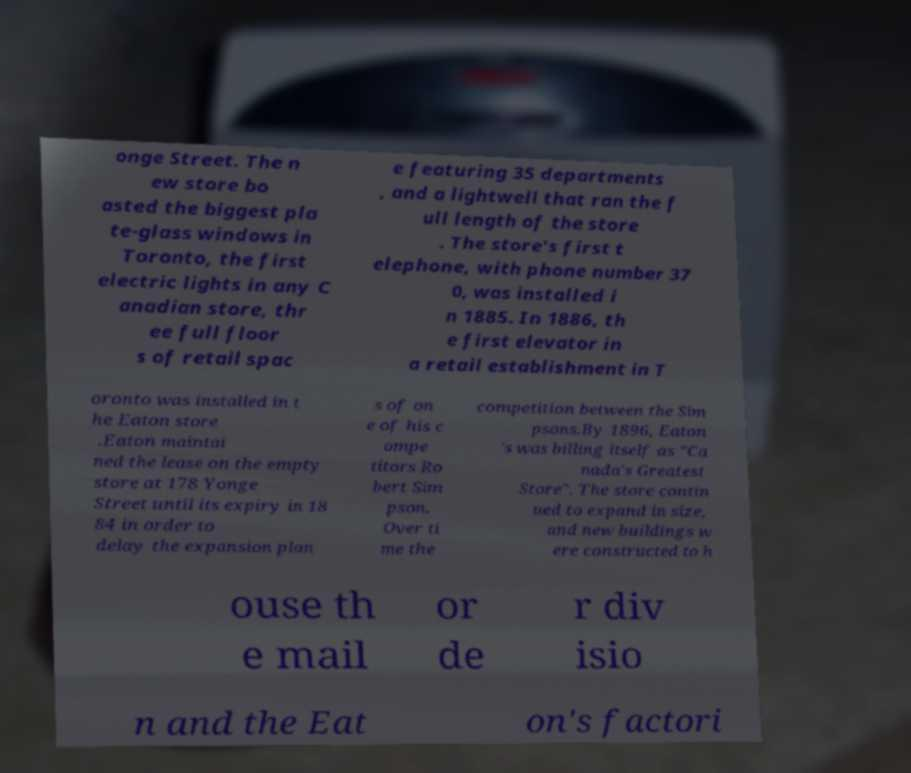I need the written content from this picture converted into text. Can you do that? onge Street. The n ew store bo asted the biggest pla te-glass windows in Toronto, the first electric lights in any C anadian store, thr ee full floor s of retail spac e featuring 35 departments , and a lightwell that ran the f ull length of the store . The store's first t elephone, with phone number 37 0, was installed i n 1885. In 1886, th e first elevator in a retail establishment in T oronto was installed in t he Eaton store .Eaton maintai ned the lease on the empty store at 178 Yonge Street until its expiry in 18 84 in order to delay the expansion plan s of on e of his c ompe titors Ro bert Sim pson. Over ti me the competition between the Sim psons.By 1896, Eaton 's was billing itself as "Ca nada's Greatest Store". The store contin ued to expand in size, and new buildings w ere constructed to h ouse th e mail or de r div isio n and the Eat on's factori 